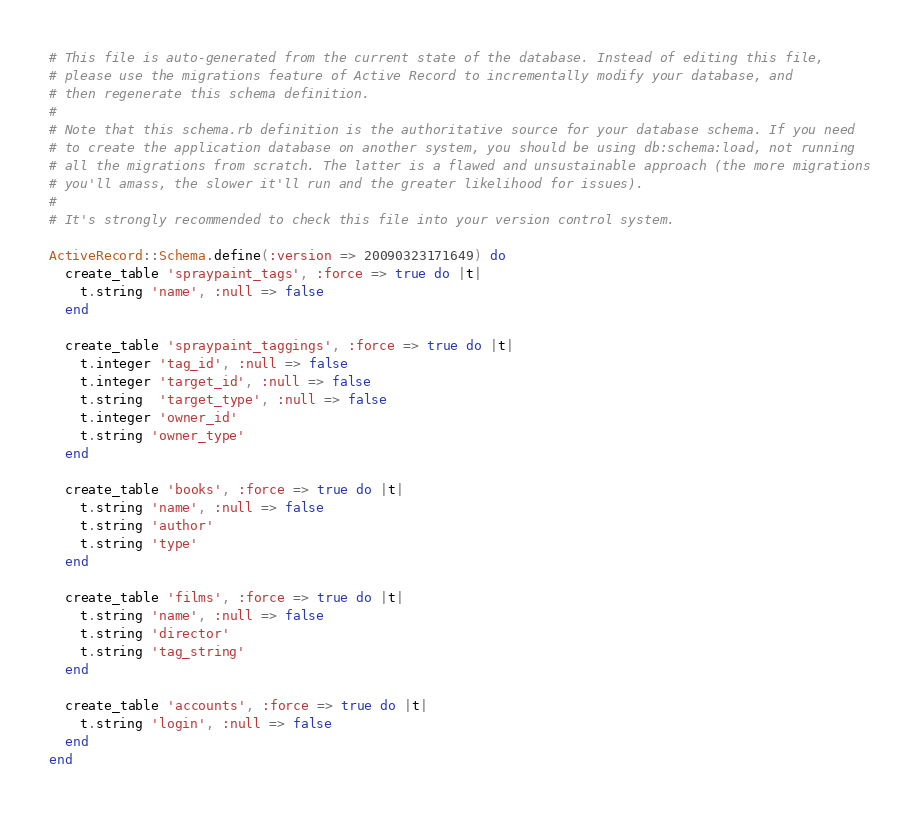Convert code to text. <code><loc_0><loc_0><loc_500><loc_500><_Ruby_># This file is auto-generated from the current state of the database. Instead of editing this file, 
# please use the migrations feature of Active Record to incrementally modify your database, and
# then regenerate this schema definition.
#
# Note that this schema.rb definition is the authoritative source for your database schema. If you need
# to create the application database on another system, you should be using db:schema:load, not running
# all the migrations from scratch. The latter is a flawed and unsustainable approach (the more migrations
# you'll amass, the slower it'll run and the greater likelihood for issues).
#
# It's strongly recommended to check this file into your version control system.

ActiveRecord::Schema.define(:version => 20090323171649) do
  create_table 'spraypaint_tags', :force => true do |t|
    t.string 'name', :null => false
  end
  
  create_table 'spraypaint_taggings', :force => true do |t|
    t.integer 'tag_id', :null => false
    t.integer 'target_id', :null => false
    t.string  'target_type', :null => false
    t.integer 'owner_id'
    t.string 'owner_type'
  end
  
  create_table 'books', :force => true do |t|
    t.string 'name', :null => false
    t.string 'author'
    t.string 'type'
  end
  
  create_table 'films', :force => true do |t|
    t.string 'name', :null => false
    t.string 'director'
    t.string 'tag_string'
  end
  
  create_table 'accounts', :force => true do |t|
    t.string 'login', :null => false
  end
end
</code> 